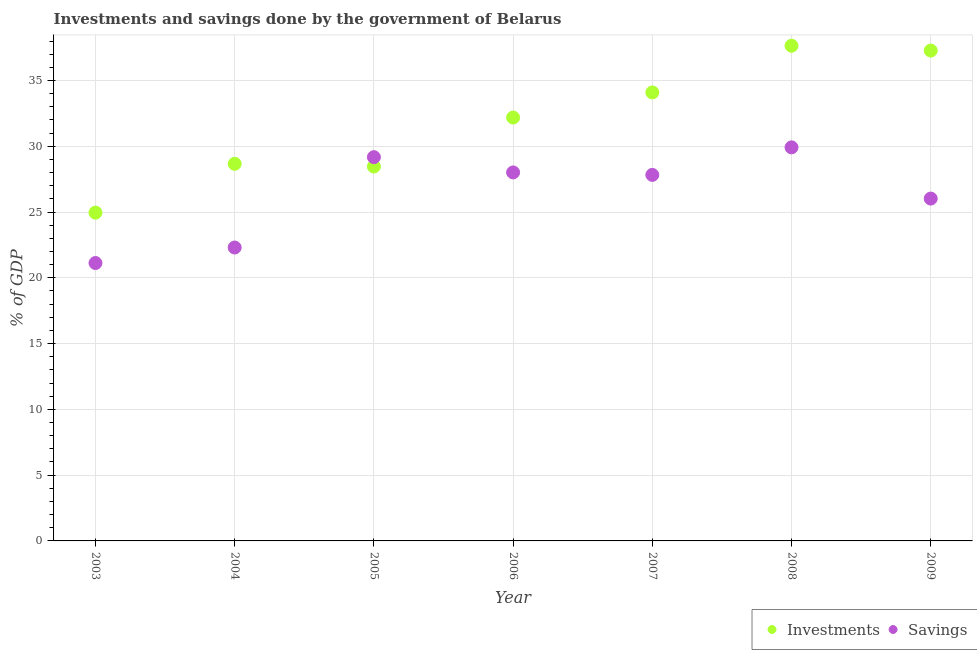How many different coloured dotlines are there?
Your answer should be compact. 2. What is the investments of government in 2007?
Your response must be concise. 34.09. Across all years, what is the maximum investments of government?
Your answer should be very brief. 37.64. Across all years, what is the minimum savings of government?
Your response must be concise. 21.13. In which year was the investments of government maximum?
Give a very brief answer. 2008. What is the total savings of government in the graph?
Your answer should be compact. 184.38. What is the difference between the investments of government in 2006 and that in 2009?
Your answer should be compact. -5.09. What is the difference between the savings of government in 2009 and the investments of government in 2005?
Provide a short and direct response. -2.44. What is the average savings of government per year?
Offer a terse response. 26.34. In the year 2009, what is the difference between the savings of government and investments of government?
Make the answer very short. -11.25. In how many years, is the savings of government greater than 11 %?
Your response must be concise. 7. What is the ratio of the savings of government in 2005 to that in 2007?
Give a very brief answer. 1.05. Is the difference between the savings of government in 2004 and 2006 greater than the difference between the investments of government in 2004 and 2006?
Your response must be concise. No. What is the difference between the highest and the second highest investments of government?
Provide a succinct answer. 0.37. What is the difference between the highest and the lowest investments of government?
Offer a very short reply. 12.69. In how many years, is the investments of government greater than the average investments of government taken over all years?
Provide a succinct answer. 4. Is the sum of the investments of government in 2004 and 2006 greater than the maximum savings of government across all years?
Ensure brevity in your answer.  Yes. Does the savings of government monotonically increase over the years?
Your answer should be compact. No. Is the savings of government strictly greater than the investments of government over the years?
Your answer should be compact. No. Is the investments of government strictly less than the savings of government over the years?
Make the answer very short. No. How many dotlines are there?
Your answer should be compact. 2. How many years are there in the graph?
Make the answer very short. 7. What is the difference between two consecutive major ticks on the Y-axis?
Offer a very short reply. 5. Does the graph contain grids?
Offer a very short reply. Yes. How many legend labels are there?
Offer a very short reply. 2. How are the legend labels stacked?
Offer a terse response. Horizontal. What is the title of the graph?
Your answer should be compact. Investments and savings done by the government of Belarus. Does "Tetanus" appear as one of the legend labels in the graph?
Offer a terse response. No. What is the label or title of the Y-axis?
Your response must be concise. % of GDP. What is the % of GDP in Investments in 2003?
Provide a succinct answer. 24.95. What is the % of GDP of Savings in 2003?
Make the answer very short. 21.13. What is the % of GDP of Investments in 2004?
Provide a short and direct response. 28.67. What is the % of GDP of Savings in 2004?
Offer a terse response. 22.3. What is the % of GDP in Investments in 2005?
Provide a succinct answer. 28.46. What is the % of GDP in Savings in 2005?
Your answer should be very brief. 29.17. What is the % of GDP in Investments in 2006?
Offer a terse response. 32.18. What is the % of GDP of Savings in 2006?
Your answer should be compact. 28.01. What is the % of GDP in Investments in 2007?
Ensure brevity in your answer.  34.09. What is the % of GDP in Savings in 2007?
Give a very brief answer. 27.82. What is the % of GDP in Investments in 2008?
Give a very brief answer. 37.64. What is the % of GDP in Savings in 2008?
Your response must be concise. 29.92. What is the % of GDP in Investments in 2009?
Your answer should be very brief. 37.27. What is the % of GDP of Savings in 2009?
Keep it short and to the point. 26.02. Across all years, what is the maximum % of GDP in Investments?
Provide a succinct answer. 37.64. Across all years, what is the maximum % of GDP in Savings?
Provide a short and direct response. 29.92. Across all years, what is the minimum % of GDP in Investments?
Offer a very short reply. 24.95. Across all years, what is the minimum % of GDP in Savings?
Your answer should be compact. 21.13. What is the total % of GDP in Investments in the graph?
Ensure brevity in your answer.  223.27. What is the total % of GDP of Savings in the graph?
Ensure brevity in your answer.  184.38. What is the difference between the % of GDP of Investments in 2003 and that in 2004?
Your answer should be very brief. -3.71. What is the difference between the % of GDP in Savings in 2003 and that in 2004?
Your response must be concise. -1.18. What is the difference between the % of GDP in Investments in 2003 and that in 2005?
Your response must be concise. -3.51. What is the difference between the % of GDP of Savings in 2003 and that in 2005?
Offer a very short reply. -8.05. What is the difference between the % of GDP of Investments in 2003 and that in 2006?
Make the answer very short. -7.23. What is the difference between the % of GDP in Savings in 2003 and that in 2006?
Provide a succinct answer. -6.89. What is the difference between the % of GDP of Investments in 2003 and that in 2007?
Your answer should be very brief. -9.14. What is the difference between the % of GDP of Savings in 2003 and that in 2007?
Make the answer very short. -6.7. What is the difference between the % of GDP of Investments in 2003 and that in 2008?
Offer a very short reply. -12.69. What is the difference between the % of GDP in Savings in 2003 and that in 2008?
Keep it short and to the point. -8.79. What is the difference between the % of GDP in Investments in 2003 and that in 2009?
Make the answer very short. -12.32. What is the difference between the % of GDP of Savings in 2003 and that in 2009?
Provide a succinct answer. -4.9. What is the difference between the % of GDP of Investments in 2004 and that in 2005?
Keep it short and to the point. 0.21. What is the difference between the % of GDP in Savings in 2004 and that in 2005?
Ensure brevity in your answer.  -6.87. What is the difference between the % of GDP in Investments in 2004 and that in 2006?
Your answer should be very brief. -3.52. What is the difference between the % of GDP in Savings in 2004 and that in 2006?
Provide a short and direct response. -5.71. What is the difference between the % of GDP in Investments in 2004 and that in 2007?
Ensure brevity in your answer.  -5.42. What is the difference between the % of GDP of Savings in 2004 and that in 2007?
Provide a short and direct response. -5.52. What is the difference between the % of GDP in Investments in 2004 and that in 2008?
Offer a terse response. -8.97. What is the difference between the % of GDP in Savings in 2004 and that in 2008?
Your answer should be very brief. -7.61. What is the difference between the % of GDP in Investments in 2004 and that in 2009?
Offer a terse response. -8.61. What is the difference between the % of GDP of Savings in 2004 and that in 2009?
Make the answer very short. -3.72. What is the difference between the % of GDP in Investments in 2005 and that in 2006?
Give a very brief answer. -3.72. What is the difference between the % of GDP in Savings in 2005 and that in 2006?
Provide a succinct answer. 1.16. What is the difference between the % of GDP in Investments in 2005 and that in 2007?
Your answer should be compact. -5.63. What is the difference between the % of GDP of Savings in 2005 and that in 2007?
Provide a short and direct response. 1.35. What is the difference between the % of GDP in Investments in 2005 and that in 2008?
Your answer should be very brief. -9.18. What is the difference between the % of GDP of Savings in 2005 and that in 2008?
Your answer should be compact. -0.75. What is the difference between the % of GDP in Investments in 2005 and that in 2009?
Provide a succinct answer. -8.81. What is the difference between the % of GDP of Savings in 2005 and that in 2009?
Your response must be concise. 3.15. What is the difference between the % of GDP in Investments in 2006 and that in 2007?
Your answer should be very brief. -1.91. What is the difference between the % of GDP of Savings in 2006 and that in 2007?
Your response must be concise. 0.19. What is the difference between the % of GDP in Investments in 2006 and that in 2008?
Ensure brevity in your answer.  -5.46. What is the difference between the % of GDP in Savings in 2006 and that in 2008?
Provide a short and direct response. -1.91. What is the difference between the % of GDP of Investments in 2006 and that in 2009?
Ensure brevity in your answer.  -5.09. What is the difference between the % of GDP in Savings in 2006 and that in 2009?
Make the answer very short. 1.99. What is the difference between the % of GDP of Investments in 2007 and that in 2008?
Ensure brevity in your answer.  -3.55. What is the difference between the % of GDP of Savings in 2007 and that in 2008?
Keep it short and to the point. -2.09. What is the difference between the % of GDP in Investments in 2007 and that in 2009?
Make the answer very short. -3.18. What is the difference between the % of GDP of Savings in 2007 and that in 2009?
Provide a short and direct response. 1.8. What is the difference between the % of GDP of Investments in 2008 and that in 2009?
Give a very brief answer. 0.37. What is the difference between the % of GDP in Savings in 2008 and that in 2009?
Provide a succinct answer. 3.89. What is the difference between the % of GDP of Investments in 2003 and the % of GDP of Savings in 2004?
Provide a short and direct response. 2.65. What is the difference between the % of GDP of Investments in 2003 and the % of GDP of Savings in 2005?
Keep it short and to the point. -4.22. What is the difference between the % of GDP of Investments in 2003 and the % of GDP of Savings in 2006?
Your response must be concise. -3.06. What is the difference between the % of GDP in Investments in 2003 and the % of GDP in Savings in 2007?
Give a very brief answer. -2.87. What is the difference between the % of GDP of Investments in 2003 and the % of GDP of Savings in 2008?
Your answer should be compact. -4.96. What is the difference between the % of GDP of Investments in 2003 and the % of GDP of Savings in 2009?
Provide a short and direct response. -1.07. What is the difference between the % of GDP of Investments in 2004 and the % of GDP of Savings in 2005?
Offer a very short reply. -0.5. What is the difference between the % of GDP of Investments in 2004 and the % of GDP of Savings in 2006?
Give a very brief answer. 0.66. What is the difference between the % of GDP in Investments in 2004 and the % of GDP in Savings in 2007?
Offer a very short reply. 0.84. What is the difference between the % of GDP in Investments in 2004 and the % of GDP in Savings in 2008?
Ensure brevity in your answer.  -1.25. What is the difference between the % of GDP of Investments in 2004 and the % of GDP of Savings in 2009?
Your answer should be compact. 2.64. What is the difference between the % of GDP of Investments in 2005 and the % of GDP of Savings in 2006?
Provide a succinct answer. 0.45. What is the difference between the % of GDP in Investments in 2005 and the % of GDP in Savings in 2007?
Give a very brief answer. 0.64. What is the difference between the % of GDP of Investments in 2005 and the % of GDP of Savings in 2008?
Ensure brevity in your answer.  -1.46. What is the difference between the % of GDP of Investments in 2005 and the % of GDP of Savings in 2009?
Your response must be concise. 2.44. What is the difference between the % of GDP in Investments in 2006 and the % of GDP in Savings in 2007?
Ensure brevity in your answer.  4.36. What is the difference between the % of GDP in Investments in 2006 and the % of GDP in Savings in 2008?
Offer a very short reply. 2.27. What is the difference between the % of GDP of Investments in 2006 and the % of GDP of Savings in 2009?
Keep it short and to the point. 6.16. What is the difference between the % of GDP in Investments in 2007 and the % of GDP in Savings in 2008?
Offer a very short reply. 4.17. What is the difference between the % of GDP of Investments in 2007 and the % of GDP of Savings in 2009?
Offer a very short reply. 8.07. What is the difference between the % of GDP of Investments in 2008 and the % of GDP of Savings in 2009?
Ensure brevity in your answer.  11.62. What is the average % of GDP in Investments per year?
Your response must be concise. 31.9. What is the average % of GDP in Savings per year?
Give a very brief answer. 26.34. In the year 2003, what is the difference between the % of GDP of Investments and % of GDP of Savings?
Give a very brief answer. 3.83. In the year 2004, what is the difference between the % of GDP in Investments and % of GDP in Savings?
Make the answer very short. 6.36. In the year 2005, what is the difference between the % of GDP in Investments and % of GDP in Savings?
Your answer should be very brief. -0.71. In the year 2006, what is the difference between the % of GDP in Investments and % of GDP in Savings?
Your answer should be compact. 4.17. In the year 2007, what is the difference between the % of GDP of Investments and % of GDP of Savings?
Give a very brief answer. 6.27. In the year 2008, what is the difference between the % of GDP in Investments and % of GDP in Savings?
Provide a succinct answer. 7.72. In the year 2009, what is the difference between the % of GDP in Investments and % of GDP in Savings?
Your response must be concise. 11.25. What is the ratio of the % of GDP of Investments in 2003 to that in 2004?
Make the answer very short. 0.87. What is the ratio of the % of GDP in Savings in 2003 to that in 2004?
Your answer should be compact. 0.95. What is the ratio of the % of GDP in Investments in 2003 to that in 2005?
Keep it short and to the point. 0.88. What is the ratio of the % of GDP of Savings in 2003 to that in 2005?
Provide a succinct answer. 0.72. What is the ratio of the % of GDP in Investments in 2003 to that in 2006?
Your answer should be compact. 0.78. What is the ratio of the % of GDP in Savings in 2003 to that in 2006?
Keep it short and to the point. 0.75. What is the ratio of the % of GDP in Investments in 2003 to that in 2007?
Offer a terse response. 0.73. What is the ratio of the % of GDP of Savings in 2003 to that in 2007?
Offer a terse response. 0.76. What is the ratio of the % of GDP of Investments in 2003 to that in 2008?
Ensure brevity in your answer.  0.66. What is the ratio of the % of GDP in Savings in 2003 to that in 2008?
Provide a short and direct response. 0.71. What is the ratio of the % of GDP in Investments in 2003 to that in 2009?
Keep it short and to the point. 0.67. What is the ratio of the % of GDP in Savings in 2003 to that in 2009?
Keep it short and to the point. 0.81. What is the ratio of the % of GDP of Investments in 2004 to that in 2005?
Make the answer very short. 1.01. What is the ratio of the % of GDP of Savings in 2004 to that in 2005?
Your answer should be very brief. 0.76. What is the ratio of the % of GDP in Investments in 2004 to that in 2006?
Your response must be concise. 0.89. What is the ratio of the % of GDP in Savings in 2004 to that in 2006?
Your answer should be very brief. 0.8. What is the ratio of the % of GDP in Investments in 2004 to that in 2007?
Ensure brevity in your answer.  0.84. What is the ratio of the % of GDP in Savings in 2004 to that in 2007?
Give a very brief answer. 0.8. What is the ratio of the % of GDP of Investments in 2004 to that in 2008?
Offer a very short reply. 0.76. What is the ratio of the % of GDP of Savings in 2004 to that in 2008?
Provide a succinct answer. 0.75. What is the ratio of the % of GDP of Investments in 2004 to that in 2009?
Your response must be concise. 0.77. What is the ratio of the % of GDP of Savings in 2004 to that in 2009?
Make the answer very short. 0.86. What is the ratio of the % of GDP of Investments in 2005 to that in 2006?
Make the answer very short. 0.88. What is the ratio of the % of GDP of Savings in 2005 to that in 2006?
Make the answer very short. 1.04. What is the ratio of the % of GDP of Investments in 2005 to that in 2007?
Keep it short and to the point. 0.83. What is the ratio of the % of GDP of Savings in 2005 to that in 2007?
Provide a succinct answer. 1.05. What is the ratio of the % of GDP in Investments in 2005 to that in 2008?
Offer a very short reply. 0.76. What is the ratio of the % of GDP of Savings in 2005 to that in 2008?
Provide a succinct answer. 0.98. What is the ratio of the % of GDP in Investments in 2005 to that in 2009?
Your answer should be very brief. 0.76. What is the ratio of the % of GDP in Savings in 2005 to that in 2009?
Keep it short and to the point. 1.12. What is the ratio of the % of GDP in Investments in 2006 to that in 2007?
Provide a succinct answer. 0.94. What is the ratio of the % of GDP of Savings in 2006 to that in 2007?
Your answer should be compact. 1.01. What is the ratio of the % of GDP of Investments in 2006 to that in 2008?
Your answer should be compact. 0.85. What is the ratio of the % of GDP of Savings in 2006 to that in 2008?
Ensure brevity in your answer.  0.94. What is the ratio of the % of GDP in Investments in 2006 to that in 2009?
Offer a very short reply. 0.86. What is the ratio of the % of GDP in Savings in 2006 to that in 2009?
Offer a terse response. 1.08. What is the ratio of the % of GDP in Investments in 2007 to that in 2008?
Provide a succinct answer. 0.91. What is the ratio of the % of GDP in Savings in 2007 to that in 2008?
Provide a succinct answer. 0.93. What is the ratio of the % of GDP of Investments in 2007 to that in 2009?
Provide a short and direct response. 0.91. What is the ratio of the % of GDP of Savings in 2007 to that in 2009?
Your answer should be very brief. 1.07. What is the ratio of the % of GDP in Investments in 2008 to that in 2009?
Provide a short and direct response. 1.01. What is the ratio of the % of GDP of Savings in 2008 to that in 2009?
Your answer should be very brief. 1.15. What is the difference between the highest and the second highest % of GDP of Investments?
Give a very brief answer. 0.37. What is the difference between the highest and the second highest % of GDP of Savings?
Your answer should be compact. 0.75. What is the difference between the highest and the lowest % of GDP in Investments?
Your answer should be very brief. 12.69. What is the difference between the highest and the lowest % of GDP of Savings?
Offer a terse response. 8.79. 